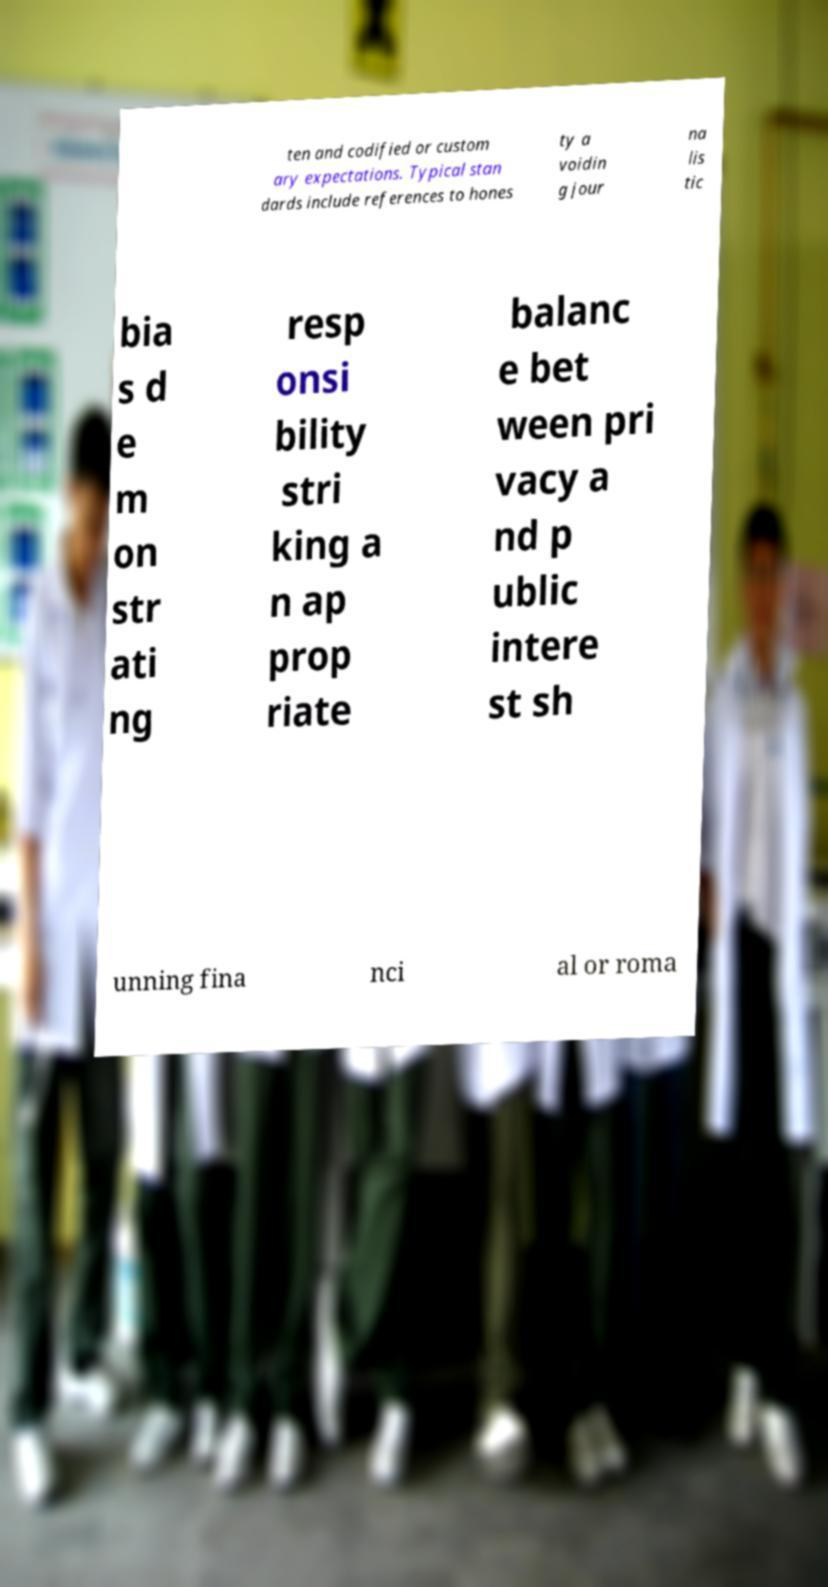For documentation purposes, I need the text within this image transcribed. Could you provide that? ten and codified or custom ary expectations. Typical stan dards include references to hones ty a voidin g jour na lis tic bia s d e m on str ati ng resp onsi bility stri king a n ap prop riate balanc e bet ween pri vacy a nd p ublic intere st sh unning fina nci al or roma 